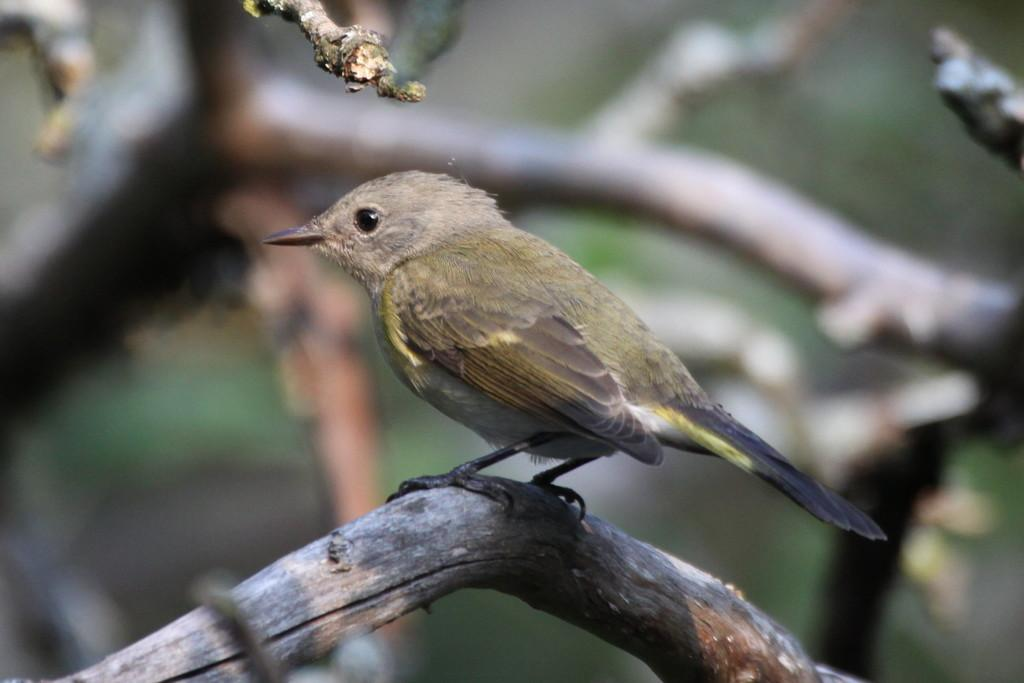What type of animal is in the image? There is a bird in the image. Where is the bird positioned in the image? The bird is on a branch. Can you describe the bird's location in relation to the image? The bird is located in the center of the image. What holiday is the mother celebrating with her servant in the image? There is no mother or servant present in the image, and therefore no such celebration can be observed. 